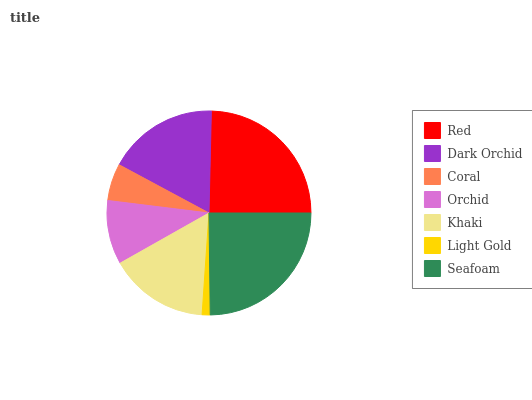Is Light Gold the minimum?
Answer yes or no. Yes. Is Seafoam the maximum?
Answer yes or no. Yes. Is Dark Orchid the minimum?
Answer yes or no. No. Is Dark Orchid the maximum?
Answer yes or no. No. Is Red greater than Dark Orchid?
Answer yes or no. Yes. Is Dark Orchid less than Red?
Answer yes or no. Yes. Is Dark Orchid greater than Red?
Answer yes or no. No. Is Red less than Dark Orchid?
Answer yes or no. No. Is Khaki the high median?
Answer yes or no. Yes. Is Khaki the low median?
Answer yes or no. Yes. Is Dark Orchid the high median?
Answer yes or no. No. Is Seafoam the low median?
Answer yes or no. No. 